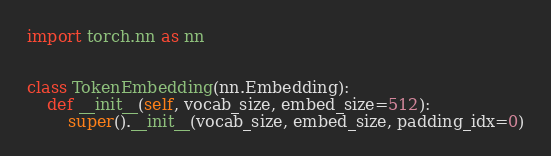<code> <loc_0><loc_0><loc_500><loc_500><_Python_>import torch.nn as nn


class TokenEmbedding(nn.Embedding):
    def __init__(self, vocab_size, embed_size=512):
        super().__init__(vocab_size, embed_size, padding_idx=0)
</code> 